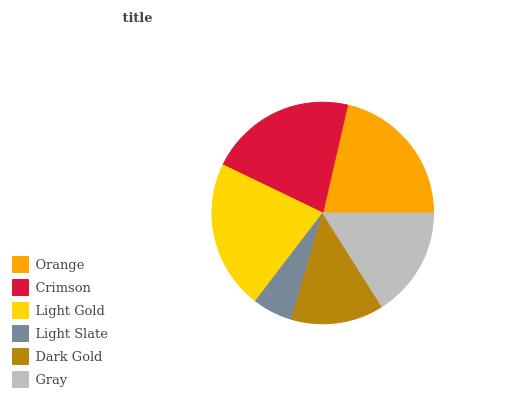Is Light Slate the minimum?
Answer yes or no. Yes. Is Light Gold the maximum?
Answer yes or no. Yes. Is Crimson the minimum?
Answer yes or no. No. Is Crimson the maximum?
Answer yes or no. No. Is Crimson greater than Orange?
Answer yes or no. Yes. Is Orange less than Crimson?
Answer yes or no. Yes. Is Orange greater than Crimson?
Answer yes or no. No. Is Crimson less than Orange?
Answer yes or no. No. Is Orange the high median?
Answer yes or no. Yes. Is Gray the low median?
Answer yes or no. Yes. Is Light Slate the high median?
Answer yes or no. No. Is Crimson the low median?
Answer yes or no. No. 